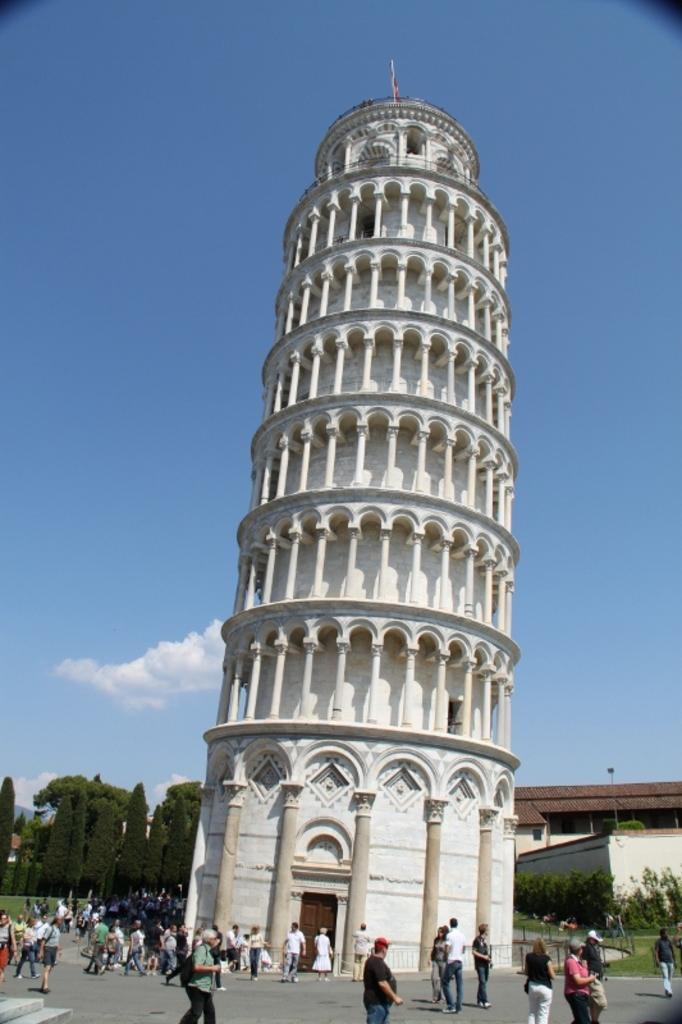What is the main structure in the center of the image? There is a tower in the center of the image. What can be seen happening in front of the tower? There are people walking on the road in front of the tower. What other structures can be seen in the image? There are buildings in the background of the image. What type of natural elements are visible in the background? There are trees and the sky visible in the background of the image. What type of zinc is used in the design of the tower? There is no mention of zinc or any specific design elements in the image, so it cannot be determined. 